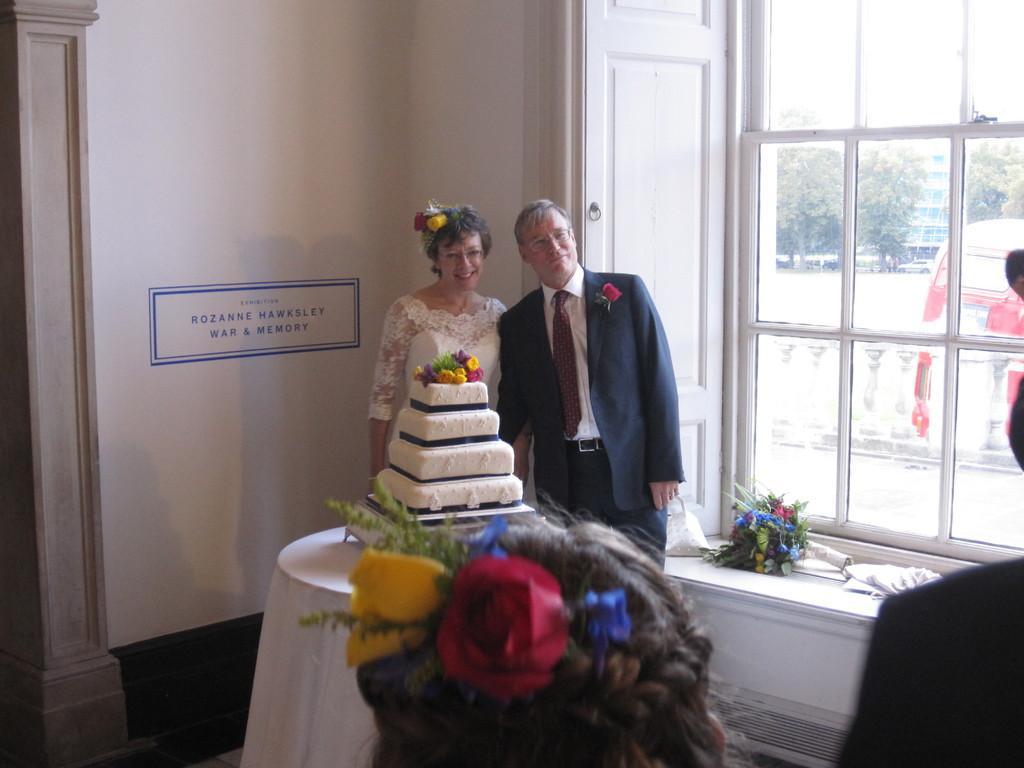Please provide a concise description of this image. Through the glass outside view is visible. We can see the trees, railing, person and a partial part of a vehicle. In this picture we can see a man and a woman. They are standing and smiling. We can see cake on a table. On the right side of the picture we can see a flower bouquet and objects on the platform. At the bottom portion of the picture we can see flowers and head of a person. In the background we can see a pillar, text on the wall. 